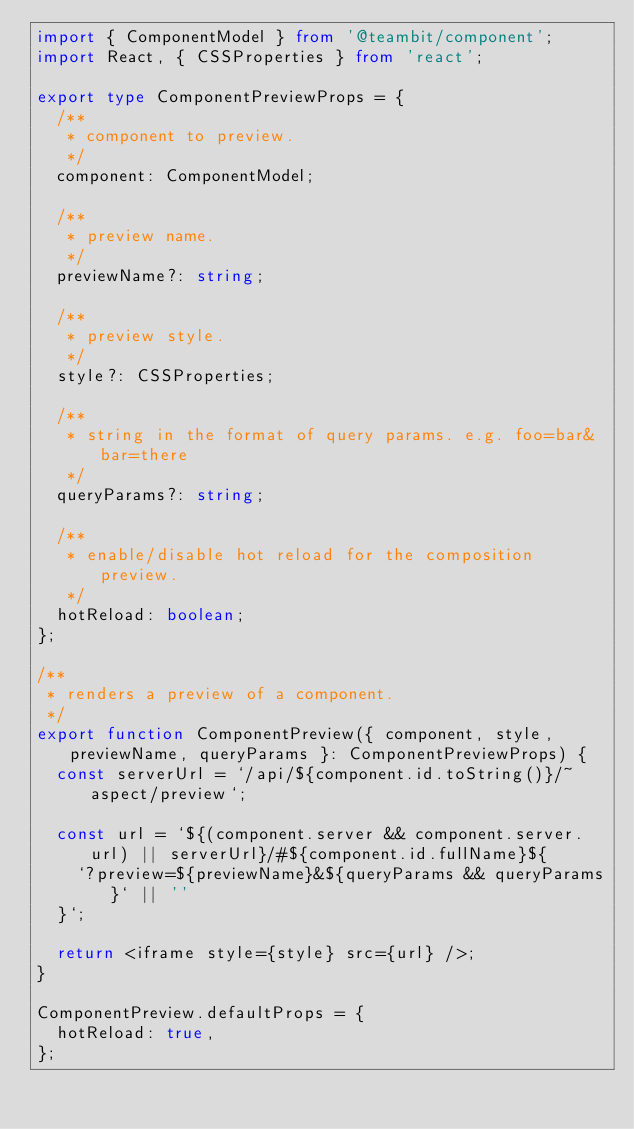Convert code to text. <code><loc_0><loc_0><loc_500><loc_500><_TypeScript_>import { ComponentModel } from '@teambit/component';
import React, { CSSProperties } from 'react';

export type ComponentPreviewProps = {
  /**
   * component to preview.
   */
  component: ComponentModel;

  /**
   * preview name.
   */
  previewName?: string;

  /**
   * preview style.
   */
  style?: CSSProperties;

  /**
   * string in the format of query params. e.g. foo=bar&bar=there
   */
  queryParams?: string;

  /**
   * enable/disable hot reload for the composition preview.
   */
  hotReload: boolean;
};

/**
 * renders a preview of a component.
 */
export function ComponentPreview({ component, style, previewName, queryParams }: ComponentPreviewProps) {
  const serverUrl = `/api/${component.id.toString()}/~aspect/preview`;

  const url = `${(component.server && component.server.url) || serverUrl}/#${component.id.fullName}${
    `?preview=${previewName}&${queryParams && queryParams}` || ''
  }`;

  return <iframe style={style} src={url} />;
}

ComponentPreview.defaultProps = {
  hotReload: true,
};
</code> 